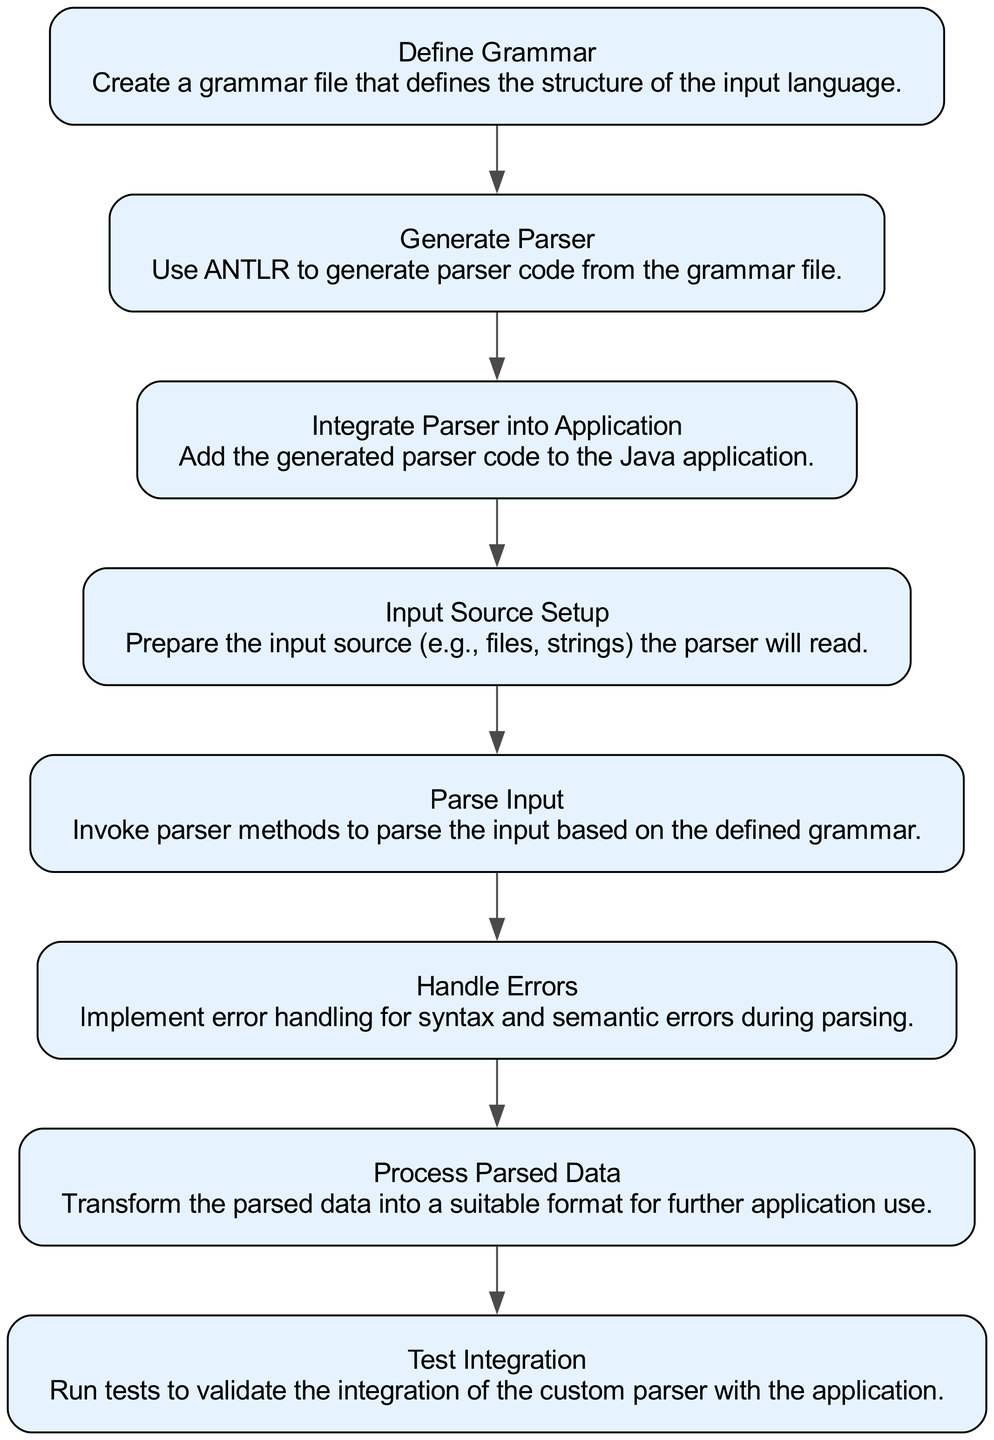What's the first step in the integration process? The first step in the flow chart is "Define Grammar," which indicates that the process begins with creating a grammar file to define the structure of the input language.
Answer: Define Grammar How many elements are in the flow chart? The flow chart contains a total of eight elements or nodes, each representing a step in the integration of the custom parser into the Java application.
Answer: 8 Which step follows "Generate Parser"? The step that follows "Generate Parser" is "Integrate Parser into Application," indicating that after the parser code generation, the next action is to incorporate that code into the application.
Answer: Integrate Parser into Application What is the relationship between "Input Source Setup" and "Parse Input"? "Input Source Setup" precedes "Parse Input," meaning that the input source must be prepared before invoking parser methods to parse the input.
Answer: Precedes What is the last step in the integration flow? The last step in the flow chart is "Test Integration," which suggests that after processing the parsed data, the final action is to run tests to validate the integration.
Answer: Test Integration How many steps are directly related to error handling? There is one step that specifically relates to error handling, which is "Handle Errors," focusing on the implementation of handling syntax and semantic errors during parsing.
Answer: 1 Which two steps are necessary before parsing input? The two necessary steps before parsing input are "Input Source Setup" and "Define Grammar," since defining the grammar is required to create the rules for parsing, and setting up the input source is required to provide data for the parser.
Answer: Input Source Setup and Define Grammar What is the purpose of the "Process Parsed Data" step? The purpose of the "Process Parsed Data" step is to transform the data that has been parsed into a format suitable for further use within the application.
Answer: Transform parsed data Which steps follow "Integrate Parser into Application"? The steps that follow "Integrate Parser into Application" are "Input Source Setup" and "Parse Input," meaning integration must first happen before setting up input and parsing.
Answer: Input Source Setup and Parse Input 